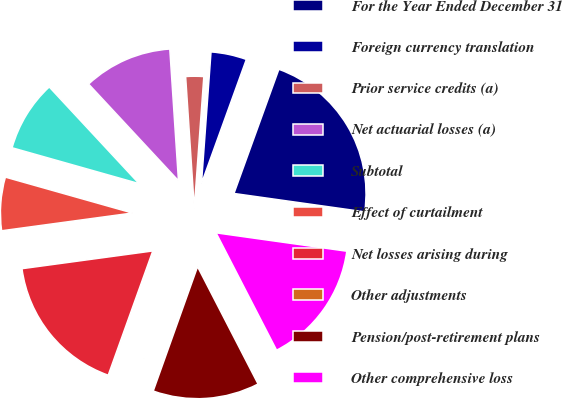Convert chart to OTSL. <chart><loc_0><loc_0><loc_500><loc_500><pie_chart><fcel>For the Year Ended December 31<fcel>Foreign currency translation<fcel>Prior service credits (a)<fcel>Net actuarial losses (a)<fcel>Subtotal<fcel>Effect of curtailment<fcel>Net losses arising during<fcel>Other adjustments<fcel>Pension/post-retirement plans<fcel>Other comprehensive loss<nl><fcel>21.7%<fcel>4.37%<fcel>2.2%<fcel>10.87%<fcel>8.7%<fcel>6.53%<fcel>17.37%<fcel>0.03%<fcel>13.03%<fcel>15.2%<nl></chart> 